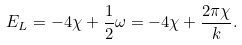<formula> <loc_0><loc_0><loc_500><loc_500>E _ { L } = - 4 \chi + \frac { 1 } { 2 } \omega = - 4 \chi + \frac { 2 \pi \chi } { k } .</formula> 